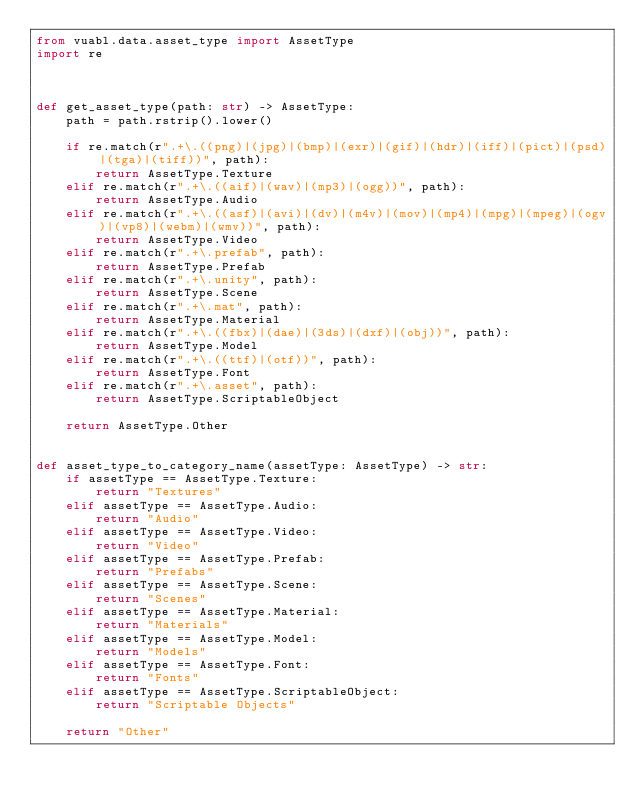Convert code to text. <code><loc_0><loc_0><loc_500><loc_500><_Python_>from vuabl.data.asset_type import AssetType
import re



def get_asset_type(path: str) -> AssetType:
    path = path.rstrip().lower()

    if re.match(r".+\.((png)|(jpg)|(bmp)|(exr)|(gif)|(hdr)|(iff)|(pict)|(psd)|(tga)|(tiff))", path):
        return AssetType.Texture
    elif re.match(r".+\.((aif)|(wav)|(mp3)|(ogg))", path):
        return AssetType.Audio
    elif re.match(r".+\.((asf)|(avi)|(dv)|(m4v)|(mov)|(mp4)|(mpg)|(mpeg)|(ogv)|(vp8)|(webm)|(wmv))", path):
        return AssetType.Video
    elif re.match(r".+\.prefab", path):
        return AssetType.Prefab
    elif re.match(r".+\.unity", path):
        return AssetType.Scene
    elif re.match(r".+\.mat", path):
        return AssetType.Material
    elif re.match(r".+\.((fbx)|(dae)|(3ds)|(dxf)|(obj))", path):
        return AssetType.Model
    elif re.match(r".+\.((ttf)|(otf))", path):
        return AssetType.Font
    elif re.match(r".+\.asset", path):
        return AssetType.ScriptableObject

    return AssetType.Other


def asset_type_to_category_name(assetType: AssetType) -> str:
    if assetType == AssetType.Texture:
        return "Textures"
    elif assetType == AssetType.Audio:
        return "Audio"
    elif assetType == AssetType.Video:
        return "Video"
    elif assetType == AssetType.Prefab:
        return "Prefabs"
    elif assetType == AssetType.Scene:
        return "Scenes"
    elif assetType == AssetType.Material:
        return "Materials"
    elif assetType == AssetType.Model:
        return "Models"
    elif assetType == AssetType.Font:
        return "Fonts"
    elif assetType == AssetType.ScriptableObject:
        return "Scriptable Objects"

    return "Other"</code> 